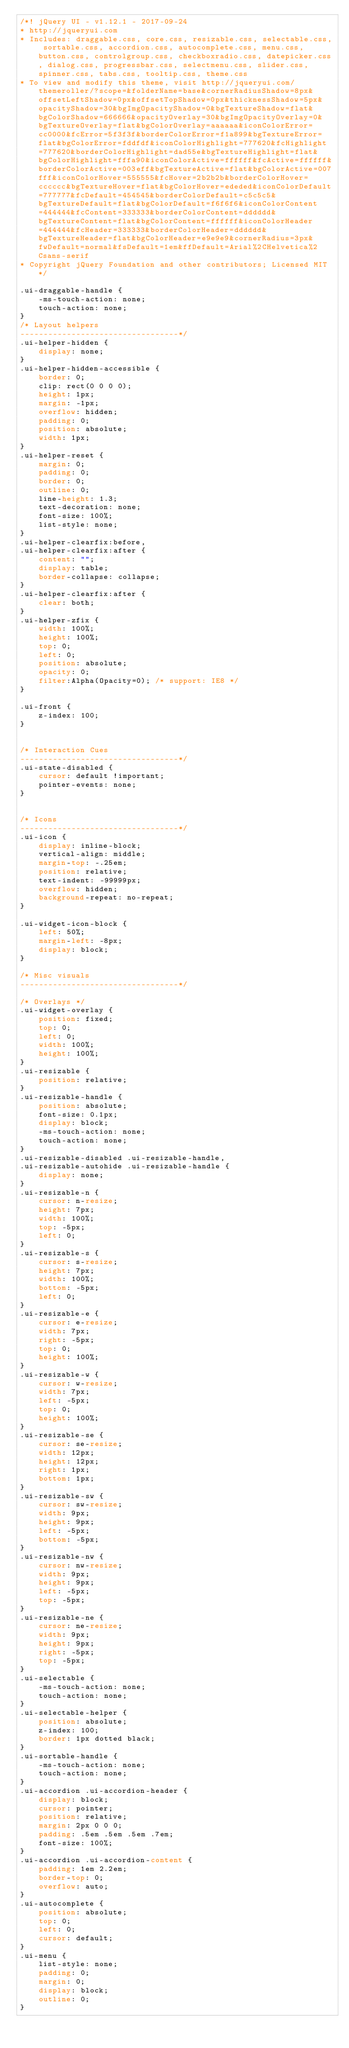Convert code to text. <code><loc_0><loc_0><loc_500><loc_500><_CSS_>/*! jQuery UI - v1.12.1 - 2017-09-24
* http://jqueryui.com
* Includes: draggable.css, core.css, resizable.css, selectable.css, sortable.css, accordion.css, autocomplete.css, menu.css, button.css, controlgroup.css, checkboxradio.css, datepicker.css, dialog.css, progressbar.css, selectmenu.css, slider.css, spinner.css, tabs.css, tooltip.css, theme.css
* To view and modify this theme, visit http://jqueryui.com/themeroller/?scope=&folderName=base&cornerRadiusShadow=8px&offsetLeftShadow=0px&offsetTopShadow=0px&thicknessShadow=5px&opacityShadow=30&bgImgOpacityShadow=0&bgTextureShadow=flat&bgColorShadow=666666&opacityOverlay=30&bgImgOpacityOverlay=0&bgTextureOverlay=flat&bgColorOverlay=aaaaaa&iconColorError=cc0000&fcError=5f3f3f&borderColorError=f1a899&bgTextureError=flat&bgColorError=fddfdf&iconColorHighlight=777620&fcHighlight=777620&borderColorHighlight=dad55e&bgTextureHighlight=flat&bgColorHighlight=fffa90&iconColorActive=ffffff&fcActive=ffffff&borderColorActive=003eff&bgTextureActive=flat&bgColorActive=007fff&iconColorHover=555555&fcHover=2b2b2b&borderColorHover=cccccc&bgTextureHover=flat&bgColorHover=ededed&iconColorDefault=777777&fcDefault=454545&borderColorDefault=c5c5c5&bgTextureDefault=flat&bgColorDefault=f6f6f6&iconColorContent=444444&fcContent=333333&borderColorContent=dddddd&bgTextureContent=flat&bgColorContent=ffffff&iconColorHeader=444444&fcHeader=333333&borderColorHeader=dddddd&bgTextureHeader=flat&bgColorHeader=e9e9e9&cornerRadius=3px&fwDefault=normal&fsDefault=1em&ffDefault=Arial%2CHelvetica%2Csans-serif
* Copyright jQuery Foundation and other contributors; Licensed MIT */

.ui-draggable-handle {
	-ms-touch-action: none;
	touch-action: none;
}
/* Layout helpers
----------------------------------*/
.ui-helper-hidden {
	display: none;
}
.ui-helper-hidden-accessible {
	border: 0;
	clip: rect(0 0 0 0);
	height: 1px;
	margin: -1px;
	overflow: hidden;
	padding: 0;
	position: absolute;
	width: 1px;
}
.ui-helper-reset {
	margin: 0;
	padding: 0;
	border: 0;
	outline: 0;
	line-height: 1.3;
	text-decoration: none;
	font-size: 100%;
	list-style: none;
}
.ui-helper-clearfix:before,
.ui-helper-clearfix:after {
	content: "";
	display: table;
	border-collapse: collapse;
}
.ui-helper-clearfix:after {
	clear: both;
}
.ui-helper-zfix {
	width: 100%;
	height: 100%;
	top: 0;
	left: 0;
	position: absolute;
	opacity: 0;
	filter:Alpha(Opacity=0); /* support: IE8 */
}

.ui-front {
	z-index: 100;
}


/* Interaction Cues
----------------------------------*/
.ui-state-disabled {
	cursor: default !important;
	pointer-events: none;
}


/* Icons
----------------------------------*/
.ui-icon {
	display: inline-block;
	vertical-align: middle;
	margin-top: -.25em;
	position: relative;
	text-indent: -99999px;
	overflow: hidden;
	background-repeat: no-repeat;
}

.ui-widget-icon-block {
	left: 50%;
	margin-left: -8px;
	display: block;
}

/* Misc visuals
----------------------------------*/

/* Overlays */
.ui-widget-overlay {
	position: fixed;
	top: 0;
	left: 0;
	width: 100%;
	height: 100%;
}
.ui-resizable {
	position: relative;
}
.ui-resizable-handle {
	position: absolute;
	font-size: 0.1px;
	display: block;
	-ms-touch-action: none;
	touch-action: none;
}
.ui-resizable-disabled .ui-resizable-handle,
.ui-resizable-autohide .ui-resizable-handle {
	display: none;
}
.ui-resizable-n {
	cursor: n-resize;
	height: 7px;
	width: 100%;
	top: -5px;
	left: 0;
}
.ui-resizable-s {
	cursor: s-resize;
	height: 7px;
	width: 100%;
	bottom: -5px;
	left: 0;
}
.ui-resizable-e {
	cursor: e-resize;
	width: 7px;
	right: -5px;
	top: 0;
	height: 100%;
}
.ui-resizable-w {
	cursor: w-resize;
	width: 7px;
	left: -5px;
	top: 0;
	height: 100%;
}
.ui-resizable-se {
	cursor: se-resize;
	width: 12px;
	height: 12px;
	right: 1px;
	bottom: 1px;
}
.ui-resizable-sw {
	cursor: sw-resize;
	width: 9px;
	height: 9px;
	left: -5px;
	bottom: -5px;
}
.ui-resizable-nw {
	cursor: nw-resize;
	width: 9px;
	height: 9px;
	left: -5px;
	top: -5px;
}
.ui-resizable-ne {
	cursor: ne-resize;
	width: 9px;
	height: 9px;
	right: -5px;
	top: -5px;
}
.ui-selectable {
	-ms-touch-action: none;
	touch-action: none;
}
.ui-selectable-helper {
	position: absolute;
	z-index: 100;
	border: 1px dotted black;
}
.ui-sortable-handle {
	-ms-touch-action: none;
	touch-action: none;
}
.ui-accordion .ui-accordion-header {
	display: block;
	cursor: pointer;
	position: relative;
	margin: 2px 0 0 0;
	padding: .5em .5em .5em .7em;
	font-size: 100%;
}
.ui-accordion .ui-accordion-content {
	padding: 1em 2.2em;
	border-top: 0;
	overflow: auto;
}
.ui-autocomplete {
	position: absolute;
	top: 0;
	left: 0;
	cursor: default;
}
.ui-menu {
	list-style: none;
	padding: 0;
	margin: 0;
	display: block;
	outline: 0;
}</code> 